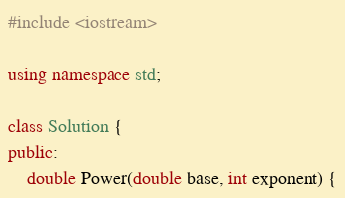Convert code to text. <code><loc_0><loc_0><loc_500><loc_500><_C++_>#include <iostream>

using namespace std;

class Solution {
public:
    double Power(double base, int exponent) {</code> 